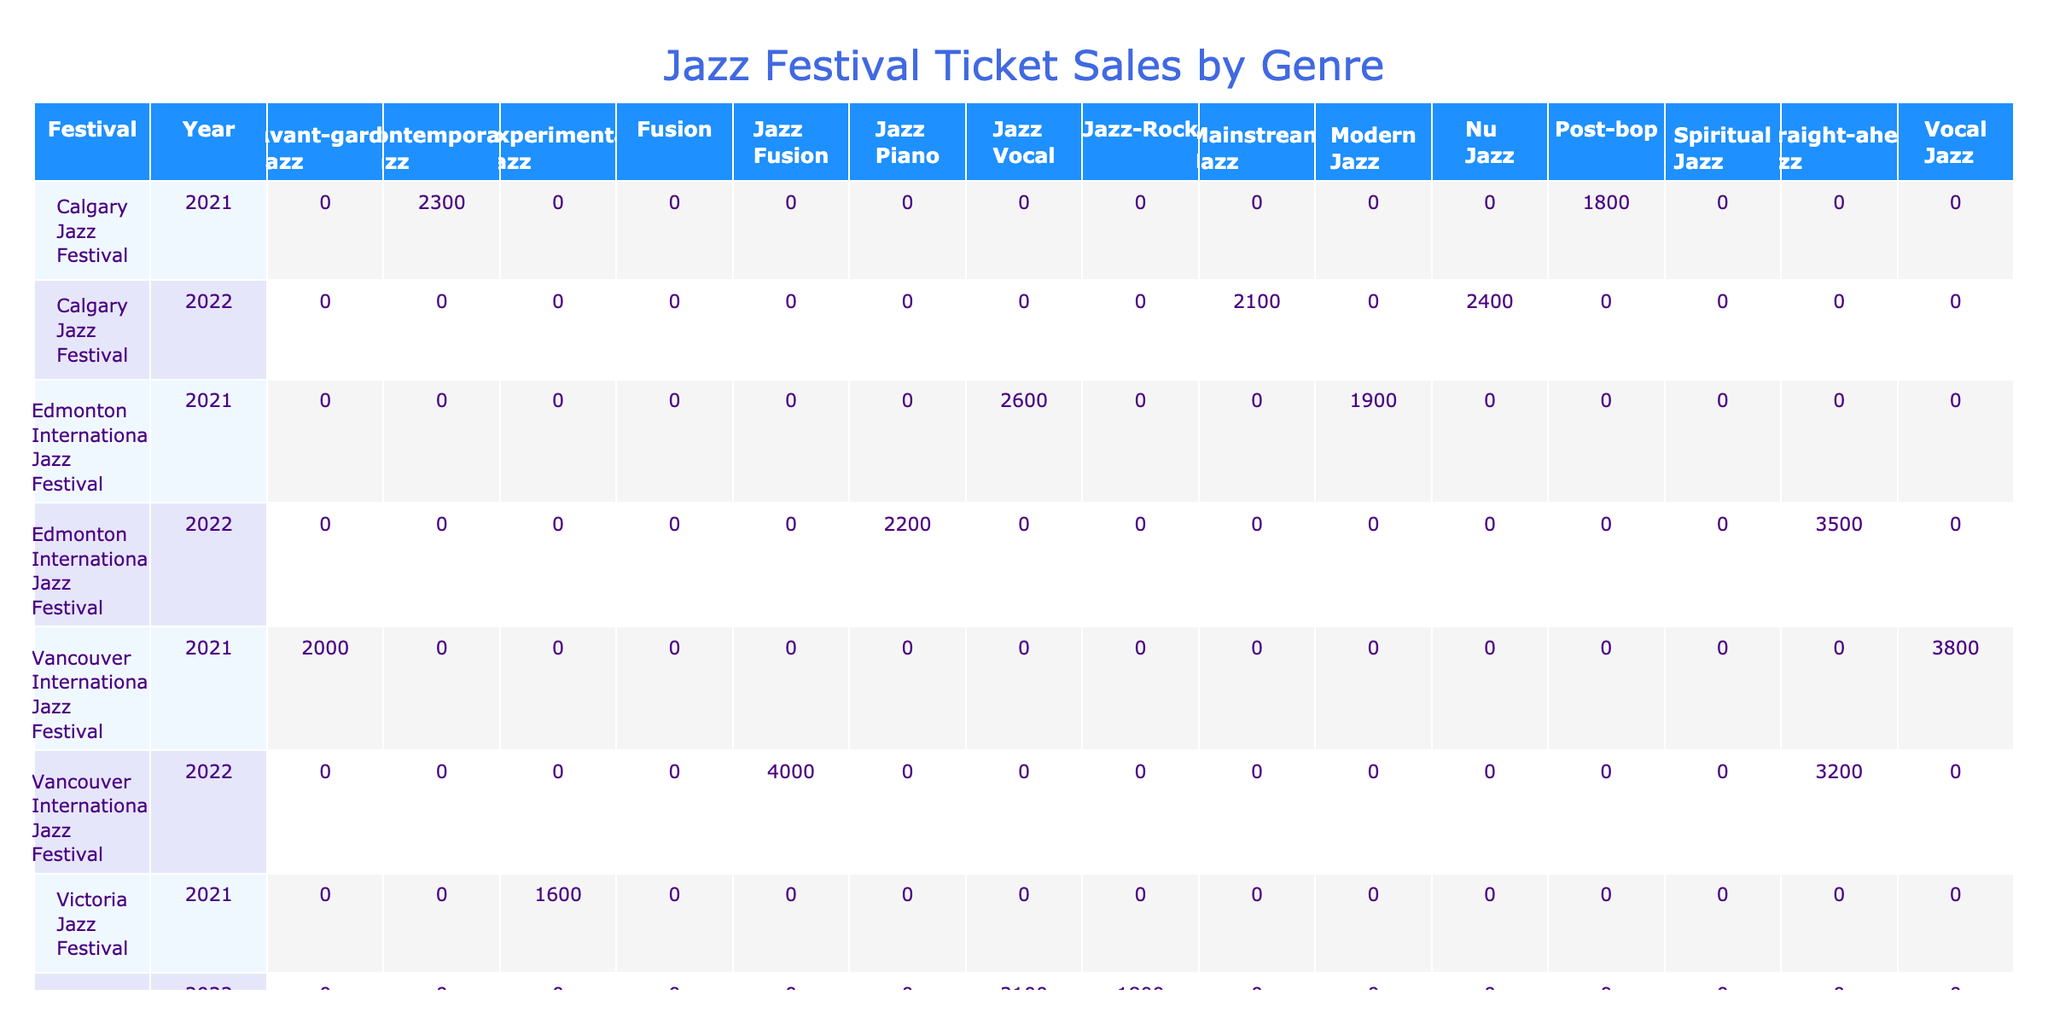What were the total ticket sales for the Winnipeg Jazz Festival in 2022? Referring to the table, the total ticket sales for the Winnipeg Jazz Festival in 2022 can be found by looking for the row with the festival name "Winnipeg Jazz Festival" and the year "2022." The entries for that row are Diana Krall (3250), Snarky Puppy (2800), and Chick Corea Elektric Band (2100). Adding these values gives: 3250 + 2800 + 2100 = 8150.
Answer: 8150 Which genre had the highest ticket sales at the Vancouver International Jazz Festival in 2022? Looking at the Vancouver International Jazz Festival in 2022, we see the ticket sales for the different genres: Jazz Fusion (4000) and Straight-ahead Jazz (3200). Comparing these values, Jazz Fusion has the highest ticket sales at 4000.
Answer: Jazz Fusion Did the Calgary Jazz Festival have better sales in 2021 compared to 2022? To answer this, we need to check the ticket sales for both years in the Calgary Jazz Festival. In 2021, the sales were contemporary jazz (2300) and post-bop (1800), summing to 4100. In 2022, the sales were 2400 (Nu Jazz) and 2100 (Mainstream Jazz), summing to 4500. Since 4500 (2022) is greater than 4100 (2021), the Calgary Jazz Festival had better sales in 2022.
Answer: Yes What is the average ticket price for artists in the Edmonton International Jazz Festival in 2021? For the Edmonton International Jazz Festival in 2021, we find the ticket prices: Gregory Porter (85) and Brad Mehldau Trio (70). The average is calculated by summing these values (85 + 70 = 155) and dividing by the number of artists (2): 155 / 2 = 77.5.
Answer: 77.5 Was Norah Jones the only artist at the Vancouver International Jazz Festival in 2021 to have ticket sales above 3000? Referring to the table for the Vancouver International Jazz Festival in 2021, ticket sales are: Norah Jones (3800) and The Bad Plus (2000). Norah Jones is above 3000, but The Bad Plus is not. Hence, Norah Jones was indeed the only artist above 3000.
Answer: Yes 